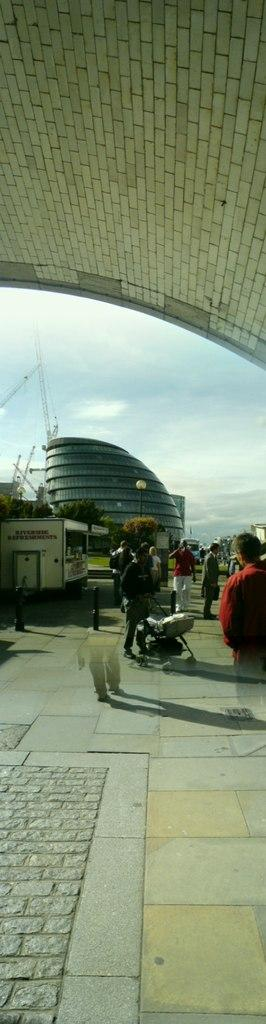What is happening on the ground in the image? There are people on the ground in the image. What can be seen in the distance behind the people? There are buildings, a roof, and the sky visible in the background of the image. Can you describe the unspecified objects in the background? Unfortunately, the provided facts do not specify the nature of the unspecified objects in the background. What country is the winged achiever from in the image? There is no winged achiever present in the image, and therefore no country of origin can be determined. 